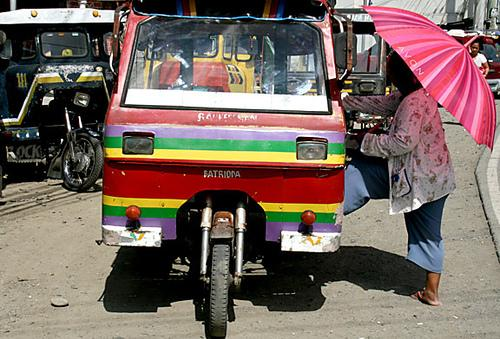Describe what the woman in the image is wearing and holding. The woman is wearing blue pants, a white sweater with a flower pattern, and bright pink flip flops. She is holding a bright pink and purple striped umbrella. For the visual entailment task, describe the type of vehicle in the image and its colors. It's a multi-colored motor cab with red, yellow, green, and red stripes. In the multi-choice VQA task, what is written on the vehicle in pink letters? There are 4 pink letters that read "AVON". For the visual entailment task, what various activities can people be seen doing in the image? People can be seen going to work, shopping, enjoying their day, and getting into a motor cab. In the multi-choice VQA task, what feature can be seen on the front of the vehicle containing lights? Stripes can be seen on the front of the vehicle. For the product advertisement task, describe some details of the tire on the vehicle in the image. The tire is made of black rubber, but it appears old and worn, signaling the need for replacement. What is happening to the motor cab in the image? A motor cab is picking someone up while people, including a woman with an umbrella, are enjoying their day out in the sunshine. For the product advertisement task, describe the umbrella a person in the image is carrying. The person is carrying a bright pink and purple striped umbrella that is perfect for protection against rain and sunshine. What type of shoes is the woman in the image wearing? The woman is wearing bright pink flip flops. For the referential expression grounding task, describe the shock absorbers seen on a vehicle in the image. The shock absorbers are made of metal, and they are grey in color. 